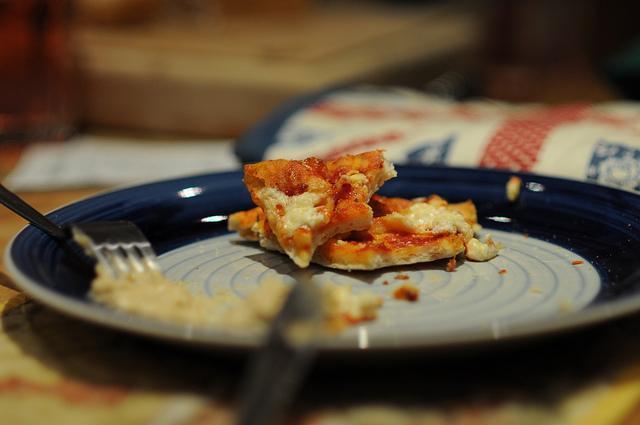How many pizzas are there?
Give a very brief answer. 2. How many people are in the photo?
Give a very brief answer. 0. 